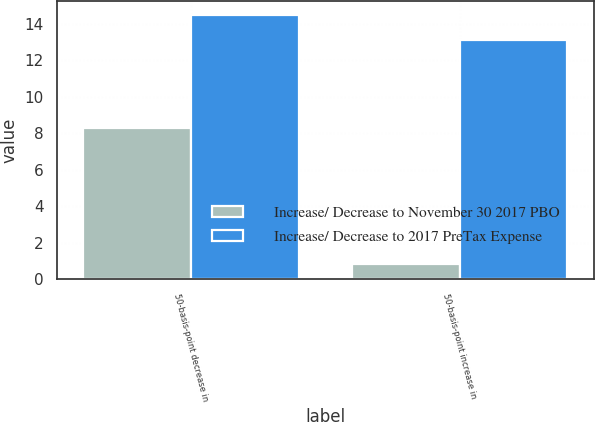Convert chart to OTSL. <chart><loc_0><loc_0><loc_500><loc_500><stacked_bar_chart><ecel><fcel>50-basis-point decrease in<fcel>50-basis-point increase in<nl><fcel>Increase/ Decrease to November 30 2017 PBO<fcel>8.3<fcel>0.8<nl><fcel>Increase/ Decrease to 2017 PreTax Expense<fcel>14.5<fcel>13.1<nl></chart> 